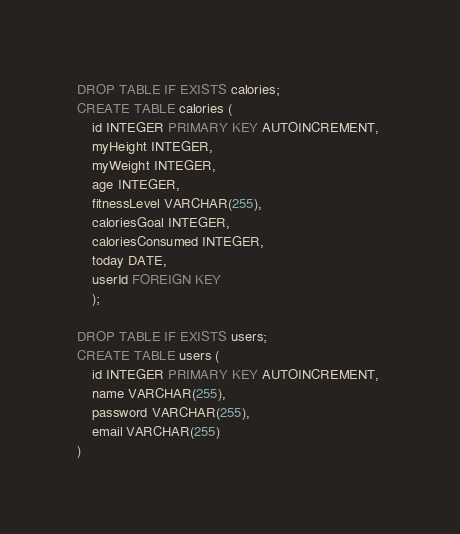<code> <loc_0><loc_0><loc_500><loc_500><_SQL_>DROP TABLE IF EXISTS calories;
CREATE TABLE calories (
    id INTEGER PRIMARY KEY AUTOINCREMENT, 
    myHeight INTEGER, 
    myWeight INTEGER, 
    age INTEGER, 
    fitnessLevel VARCHAR(255), 
    caloriesGoal INTEGER, 
    caloriesConsumed INTEGER,
    today DATE, 
    userId FOREIGN KEY
    );

DROP TABLE IF EXISTS users;
CREATE TABLE users (
    id INTEGER PRIMARY KEY AUTOINCREMENT,
    name VARCHAR(255),
    password VARCHAR(255),
    email VARCHAR(255)
)</code> 